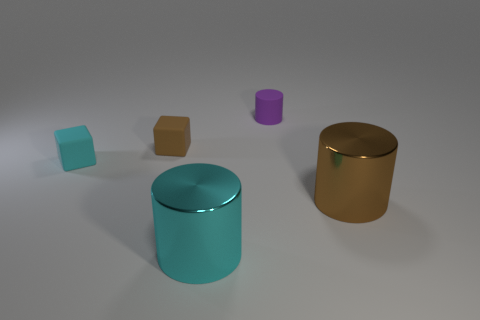There is another large metallic object that is the same shape as the cyan metal thing; what is its color?
Provide a short and direct response. Brown. What number of objects are both to the left of the tiny purple thing and behind the big brown metal object?
Make the answer very short. 2. What is the shape of the large cyan thing on the left side of the purple thing?
Provide a succinct answer. Cylinder. How many other objects are the same material as the small brown thing?
Ensure brevity in your answer.  2. What is the material of the small cyan cube?
Ensure brevity in your answer.  Rubber. What number of large things are either rubber objects or cyan shiny objects?
Your response must be concise. 1. There is a tiny purple matte cylinder; how many big things are behind it?
Provide a succinct answer. 0. There is a brown object that is the same size as the cyan shiny object; what is its shape?
Keep it short and to the point. Cylinder. What number of yellow things are either large shiny cylinders or matte things?
Keep it short and to the point. 0. What number of cyan cylinders are the same size as the cyan block?
Offer a very short reply. 0. 